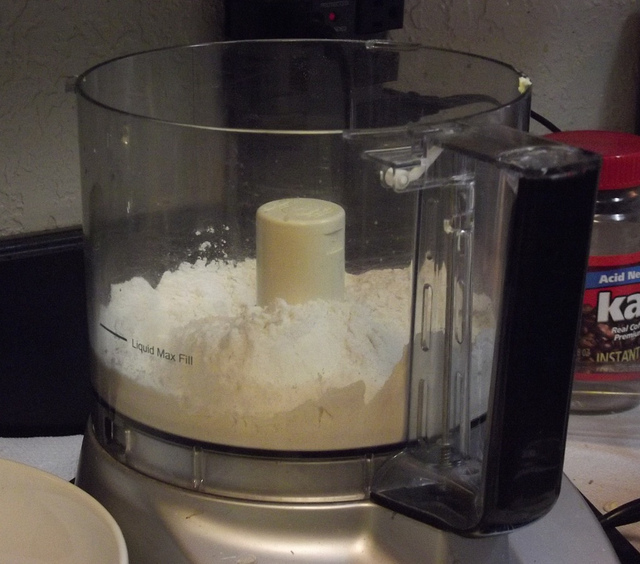Please extract the text content from this image. Liquid Max Fill Acid INSTANT Ka 